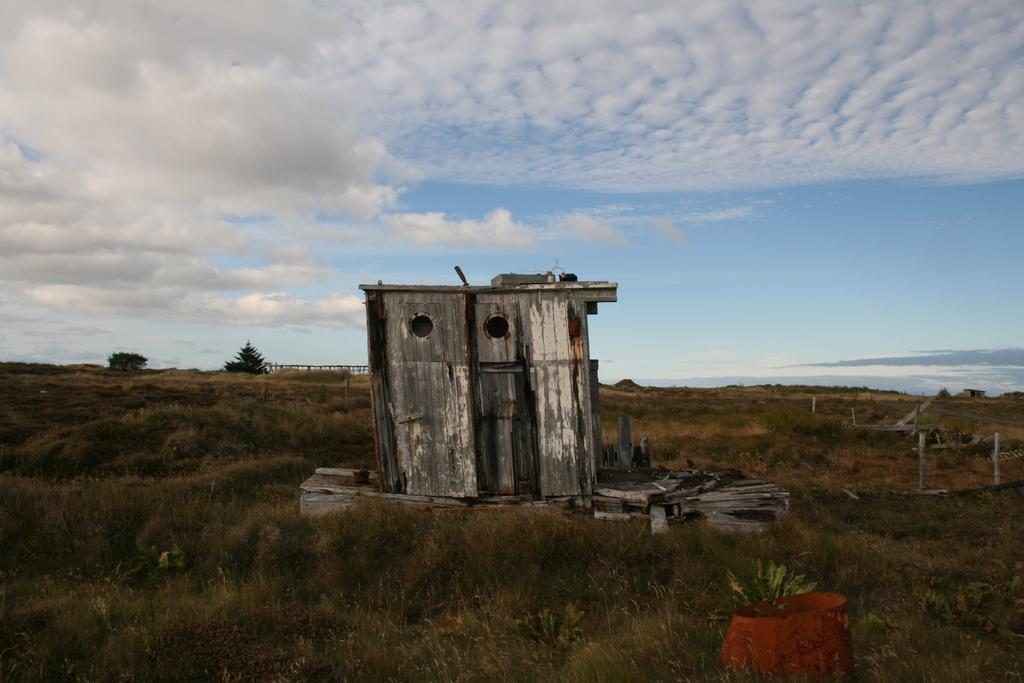What can be seen in the sky in the image? The sky is visible in the image, and clouds are present. What type of vegetation is in the image? Trees, grass, and plants are present in the image. What structures can be seen in the image? Poles, a wooden house, and a fence are present in the image. What is the color of the brown object in the image? There is a brown color object in the image, but the specific color cannot be determined without more information. Can you describe the other objects in the image? There are a few other objects in the image, but their details cannot be determined without more information. How many women are present in the image? There are no women present in the image. What type of beef is being cooked in the image? There is no beef present in the image. What legal advice is the lawyer providing in the image? There is no lawyer present in the image. 